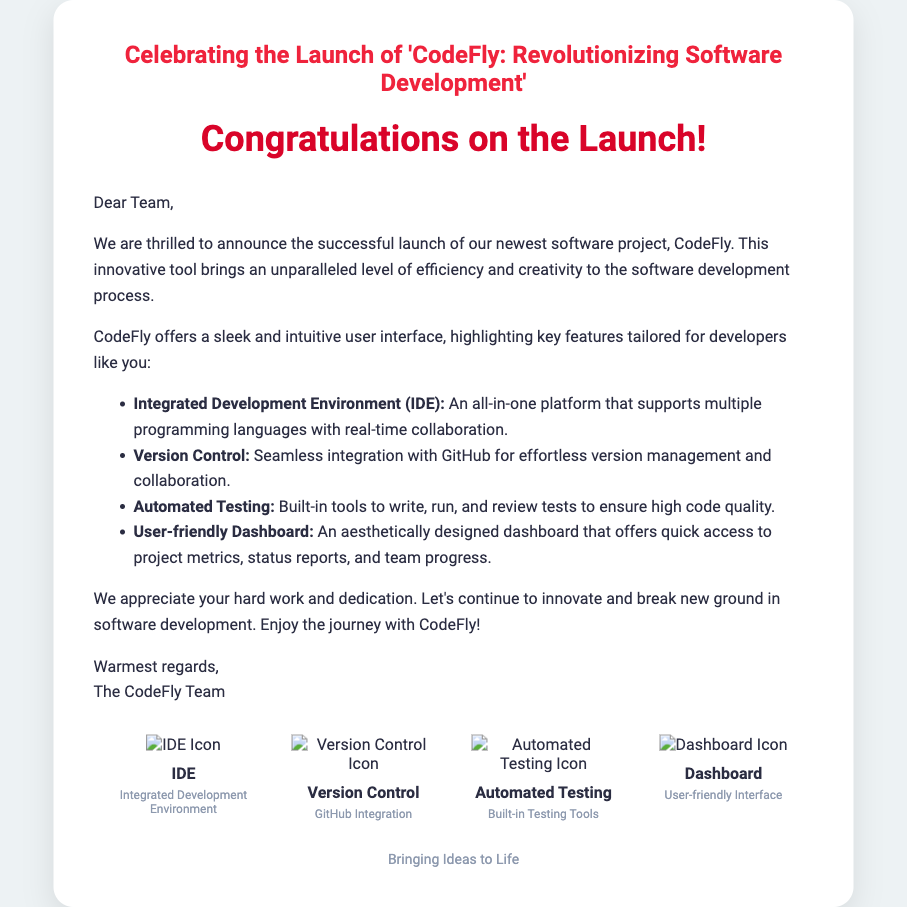What is the title of the project launched? The title of the project is found in the header section of the card, which states, "Celebrating the Launch of 'CodeFly: Revolutionizing Software Development'."
Answer: CodeFly: Revolutionizing Software Development Who is the greeting card addressed to? The card starts with "Dear Team," indicating that it is addressed to the team involved in the project.
Answer: Team What is the first feature mentioned in the list? The first feature mentioned is an "Integrated Development Environment (IDE)," based on the order of listing in the message.
Answer: Integrated Development Environment (IDE) How many features are highlighted in the card? The document lists four distinct features, as outlined in the features section.
Answer: Four What color is used for the greeting text? The greeting text color is specified in the styling part of the document, which is a bright red hue.
Answer: Red What is the purpose of CodeFly as described? The card describes CodeFly as a tool that brings efficiency and creativity to the software development process.
Answer: Efficiency and creativity in software development What visual style does the card's design mimic? The design of the card mimics a user interface, which is indicated by the structured layout and use of icons.
Answer: User interface What is included in the footer of the card? The footer contains a motivational phrase, summarizing the aim or essence of the initiative represented by CodeFly.
Answer: Bringing Ideas to Life What is one of the features related to testing mentioned in the card? The card mentions "Automated Testing" as one of the key features of the project.
Answer: Automated Testing 